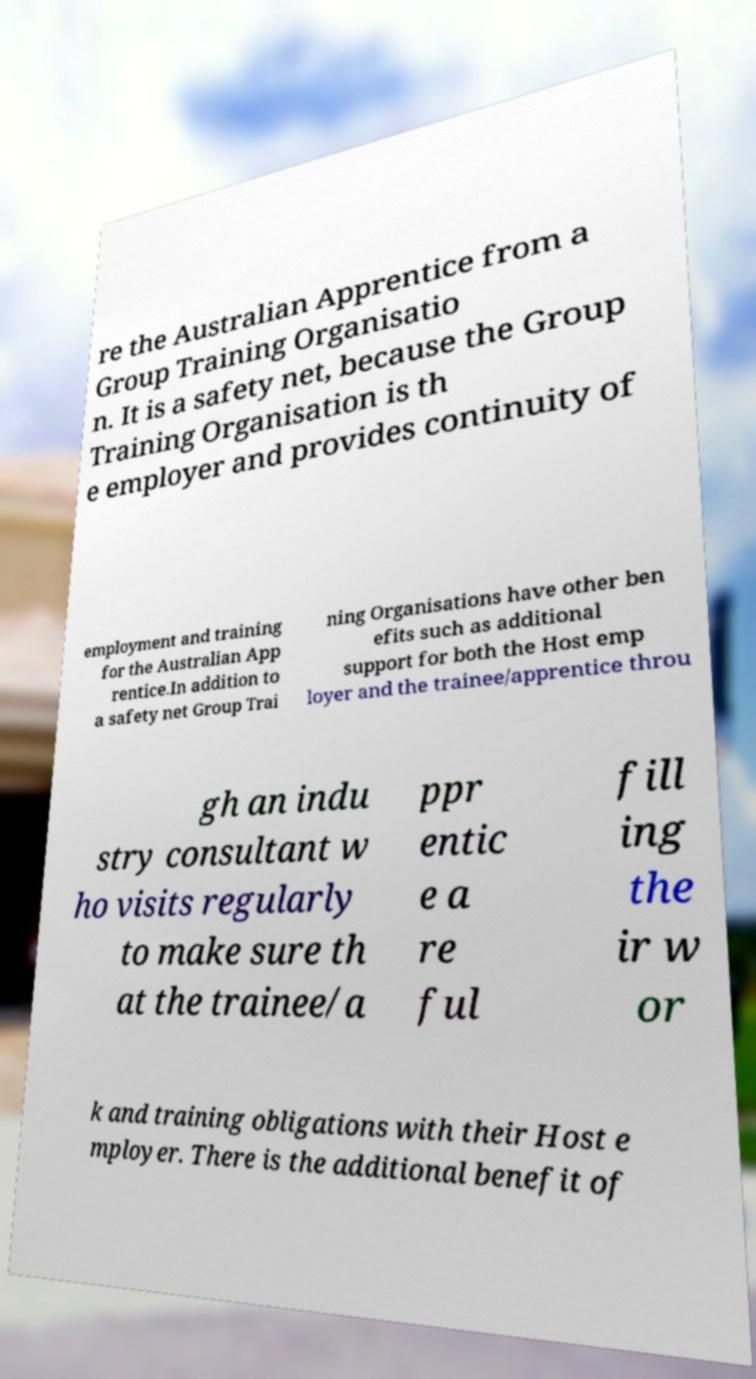Can you read and provide the text displayed in the image?This photo seems to have some interesting text. Can you extract and type it out for me? re the Australian Apprentice from a Group Training Organisatio n. It is a safety net, because the Group Training Organisation is th e employer and provides continuity of employment and training for the Australian App rentice.In addition to a safety net Group Trai ning Organisations have other ben efits such as additional support for both the Host emp loyer and the trainee/apprentice throu gh an indu stry consultant w ho visits regularly to make sure th at the trainee/a ppr entic e a re ful fill ing the ir w or k and training obligations with their Host e mployer. There is the additional benefit of 